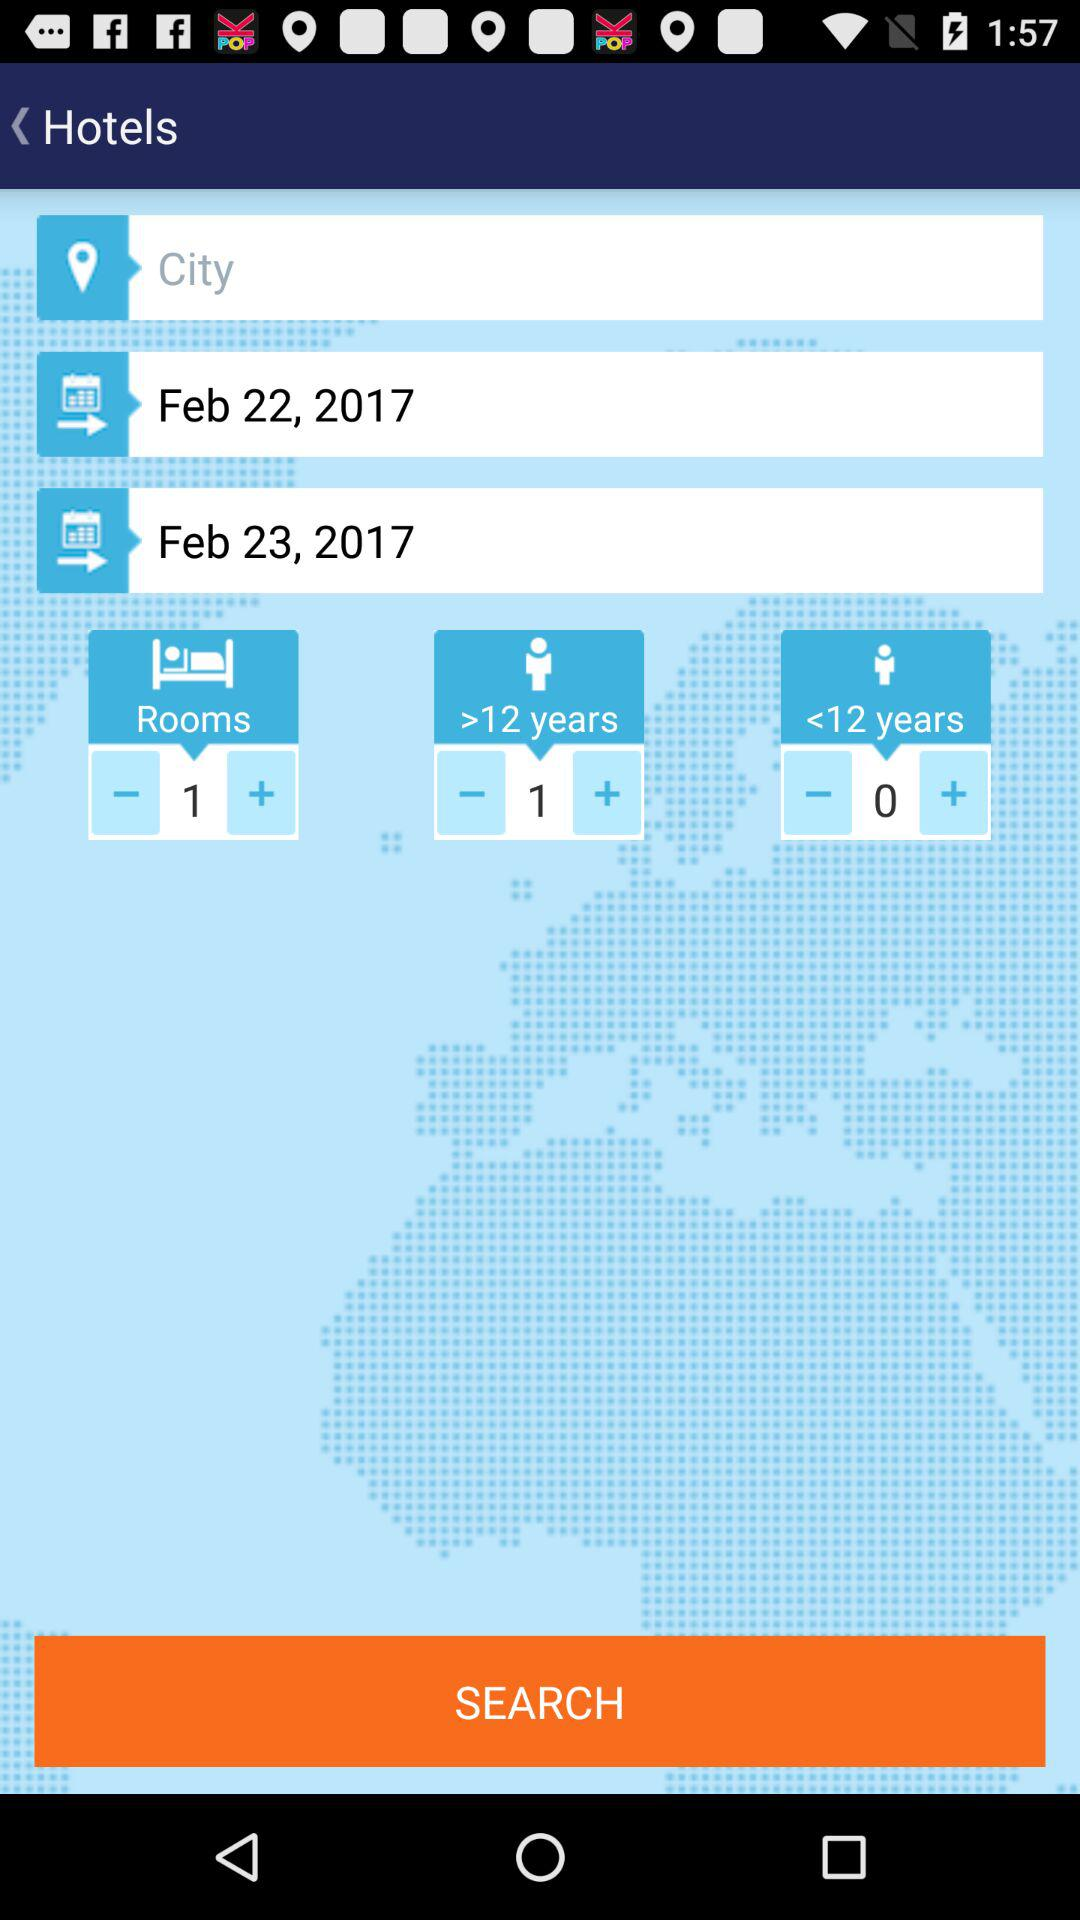What is the start date? The start date is February 22, 2017. 